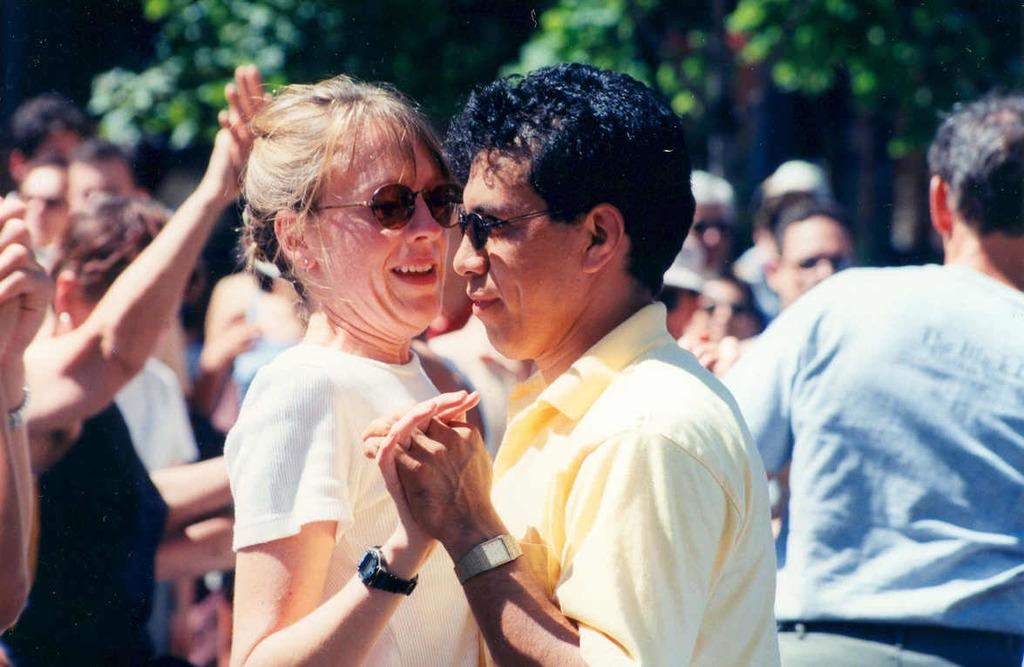How many people are in the group that is visible in the image? There is a group of people in the image, but the exact number is not specified. What accessories can be seen on some of the people in the group? Some people in the group are wearing spectacles and watches. What can be seen in the background of the image? There are trees visible in the background of the image, although they are blurry. What type of honey is being drizzled on the bean in the image? There is no honey, bean, or any food items present in the image; it features a group of people with some wearing spectacles and watches. 